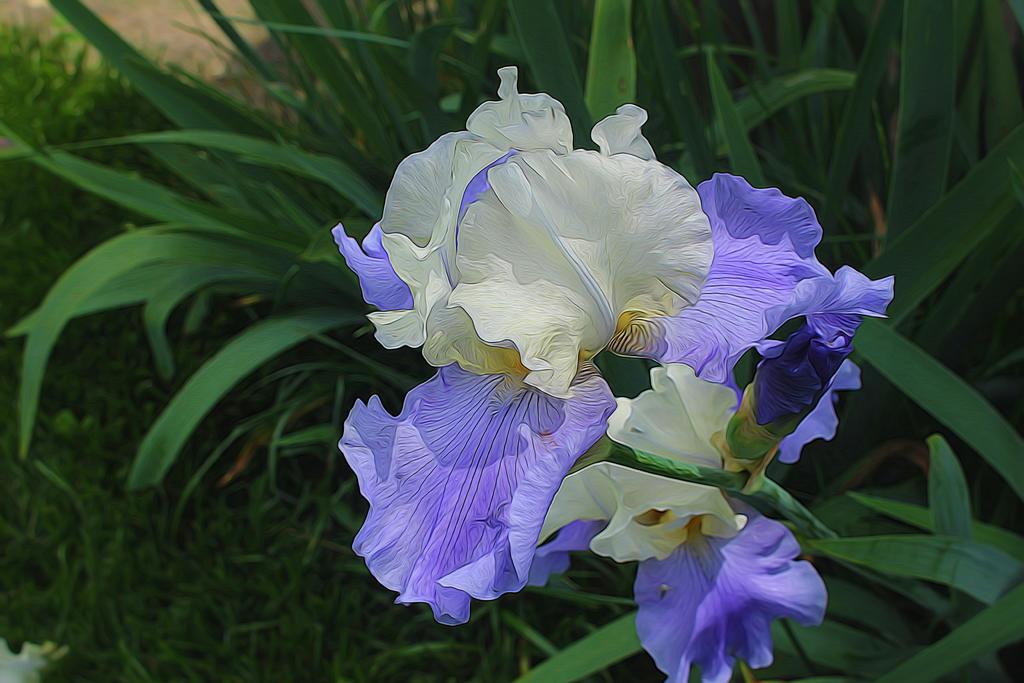What type of natural elements are present in the image? The image contains grass and plants. Can you describe any specific flora in the image? There is a flower in the image. What colors are present in the flower? The flower is in purple and white color. How many dimes can be seen scattered among the plants in the image? There are no dimes present in the image; it only contains grass, plants, and a flower. 